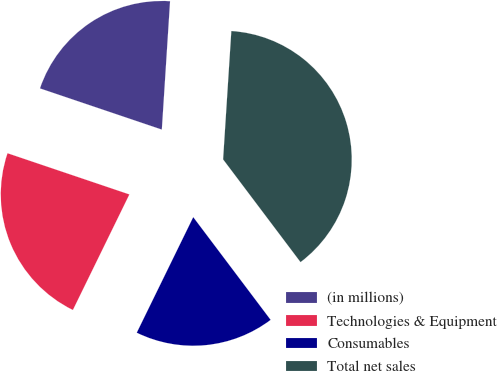<chart> <loc_0><loc_0><loc_500><loc_500><pie_chart><fcel>(in millions)<fcel>Technologies & Equipment<fcel>Consumables<fcel>Total net sales<nl><fcel>20.83%<fcel>22.95%<fcel>17.51%<fcel>38.7%<nl></chart> 